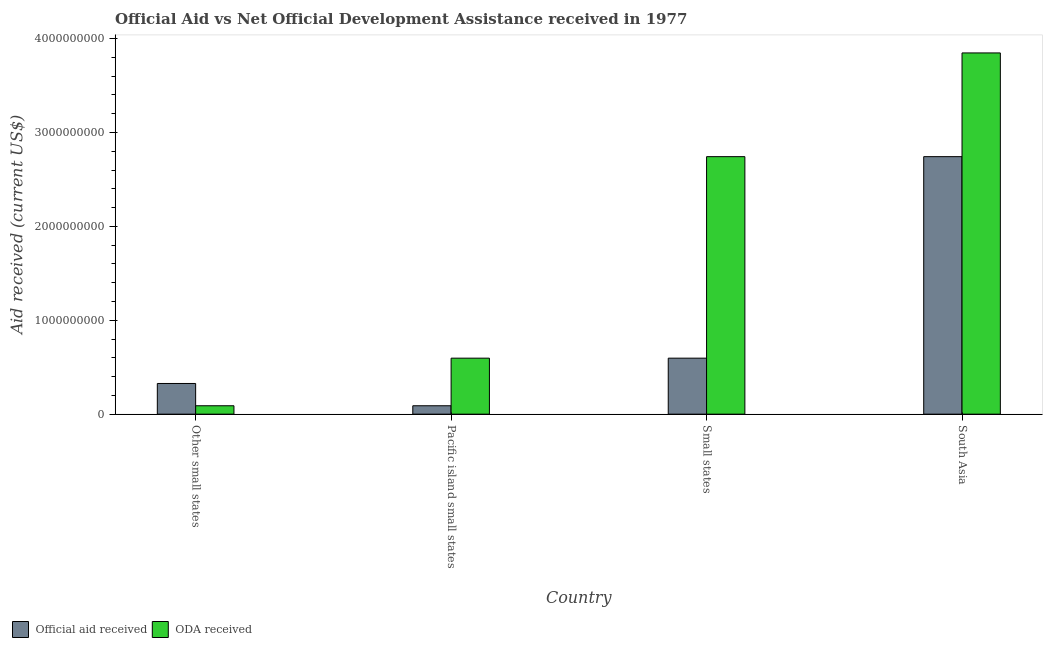Are the number of bars per tick equal to the number of legend labels?
Provide a succinct answer. Yes. Are the number of bars on each tick of the X-axis equal?
Your answer should be very brief. Yes. How many bars are there on the 4th tick from the left?
Your answer should be compact. 2. What is the label of the 3rd group of bars from the left?
Offer a very short reply. Small states. What is the official aid received in South Asia?
Offer a terse response. 2.74e+09. Across all countries, what is the maximum oda received?
Your answer should be very brief. 3.85e+09. Across all countries, what is the minimum official aid received?
Provide a short and direct response. 8.96e+07. In which country was the oda received minimum?
Provide a succinct answer. Other small states. What is the total official aid received in the graph?
Offer a very short reply. 3.76e+09. What is the difference between the oda received in Pacific island small states and that in Small states?
Keep it short and to the point. -2.15e+09. What is the difference between the official aid received in Small states and the oda received in South Asia?
Offer a terse response. -3.25e+09. What is the average official aid received per country?
Offer a terse response. 9.39e+08. What is the difference between the official aid received and oda received in Small states?
Ensure brevity in your answer.  -2.15e+09. In how many countries, is the oda received greater than 3800000000 US$?
Your answer should be compact. 1. What is the ratio of the oda received in Other small states to that in Small states?
Give a very brief answer. 0.03. Is the difference between the oda received in Other small states and South Asia greater than the difference between the official aid received in Other small states and South Asia?
Your response must be concise. No. What is the difference between the highest and the second highest oda received?
Provide a succinct answer. 1.10e+09. What is the difference between the highest and the lowest official aid received?
Your response must be concise. 2.65e+09. What does the 1st bar from the left in Other small states represents?
Your answer should be compact. Official aid received. What does the 1st bar from the right in Small states represents?
Your answer should be compact. ODA received. How many bars are there?
Offer a terse response. 8. What is the difference between two consecutive major ticks on the Y-axis?
Provide a succinct answer. 1.00e+09. Does the graph contain any zero values?
Ensure brevity in your answer.  No. Does the graph contain grids?
Offer a very short reply. No. How are the legend labels stacked?
Make the answer very short. Horizontal. What is the title of the graph?
Make the answer very short. Official Aid vs Net Official Development Assistance received in 1977 . Does "Chemicals" appear as one of the legend labels in the graph?
Your answer should be very brief. No. What is the label or title of the Y-axis?
Your answer should be compact. Aid received (current US$). What is the Aid received (current US$) in Official aid received in Other small states?
Provide a succinct answer. 3.27e+08. What is the Aid received (current US$) in ODA received in Other small states?
Offer a very short reply. 8.96e+07. What is the Aid received (current US$) of Official aid received in Pacific island small states?
Keep it short and to the point. 8.96e+07. What is the Aid received (current US$) of ODA received in Pacific island small states?
Provide a succinct answer. 5.96e+08. What is the Aid received (current US$) in Official aid received in Small states?
Your response must be concise. 5.96e+08. What is the Aid received (current US$) of ODA received in Small states?
Offer a very short reply. 2.74e+09. What is the Aid received (current US$) of Official aid received in South Asia?
Your answer should be compact. 2.74e+09. What is the Aid received (current US$) in ODA received in South Asia?
Your answer should be compact. 3.85e+09. Across all countries, what is the maximum Aid received (current US$) of Official aid received?
Offer a terse response. 2.74e+09. Across all countries, what is the maximum Aid received (current US$) in ODA received?
Keep it short and to the point. 3.85e+09. Across all countries, what is the minimum Aid received (current US$) of Official aid received?
Offer a terse response. 8.96e+07. Across all countries, what is the minimum Aid received (current US$) of ODA received?
Your answer should be compact. 8.96e+07. What is the total Aid received (current US$) of Official aid received in the graph?
Provide a succinct answer. 3.76e+09. What is the total Aid received (current US$) in ODA received in the graph?
Provide a succinct answer. 7.28e+09. What is the difference between the Aid received (current US$) in Official aid received in Other small states and that in Pacific island small states?
Your answer should be compact. 2.37e+08. What is the difference between the Aid received (current US$) of ODA received in Other small states and that in Pacific island small states?
Provide a succinct answer. -5.07e+08. What is the difference between the Aid received (current US$) in Official aid received in Other small states and that in Small states?
Your response must be concise. -2.70e+08. What is the difference between the Aid received (current US$) in ODA received in Other small states and that in Small states?
Provide a short and direct response. -2.65e+09. What is the difference between the Aid received (current US$) of Official aid received in Other small states and that in South Asia?
Give a very brief answer. -2.42e+09. What is the difference between the Aid received (current US$) in ODA received in Other small states and that in South Asia?
Provide a succinct answer. -3.76e+09. What is the difference between the Aid received (current US$) of Official aid received in Pacific island small states and that in Small states?
Your answer should be very brief. -5.07e+08. What is the difference between the Aid received (current US$) of ODA received in Pacific island small states and that in Small states?
Make the answer very short. -2.15e+09. What is the difference between the Aid received (current US$) in Official aid received in Pacific island small states and that in South Asia?
Give a very brief answer. -2.65e+09. What is the difference between the Aid received (current US$) in ODA received in Pacific island small states and that in South Asia?
Provide a succinct answer. -3.25e+09. What is the difference between the Aid received (current US$) in Official aid received in Small states and that in South Asia?
Your response must be concise. -2.15e+09. What is the difference between the Aid received (current US$) in ODA received in Small states and that in South Asia?
Provide a succinct answer. -1.10e+09. What is the difference between the Aid received (current US$) of Official aid received in Other small states and the Aid received (current US$) of ODA received in Pacific island small states?
Provide a short and direct response. -2.70e+08. What is the difference between the Aid received (current US$) in Official aid received in Other small states and the Aid received (current US$) in ODA received in Small states?
Make the answer very short. -2.42e+09. What is the difference between the Aid received (current US$) in Official aid received in Other small states and the Aid received (current US$) in ODA received in South Asia?
Offer a very short reply. -3.52e+09. What is the difference between the Aid received (current US$) of Official aid received in Pacific island small states and the Aid received (current US$) of ODA received in Small states?
Ensure brevity in your answer.  -2.65e+09. What is the difference between the Aid received (current US$) of Official aid received in Pacific island small states and the Aid received (current US$) of ODA received in South Asia?
Your answer should be compact. -3.76e+09. What is the difference between the Aid received (current US$) in Official aid received in Small states and the Aid received (current US$) in ODA received in South Asia?
Keep it short and to the point. -3.25e+09. What is the average Aid received (current US$) of Official aid received per country?
Offer a terse response. 9.39e+08. What is the average Aid received (current US$) in ODA received per country?
Offer a very short reply. 1.82e+09. What is the difference between the Aid received (current US$) in Official aid received and Aid received (current US$) in ODA received in Other small states?
Give a very brief answer. 2.37e+08. What is the difference between the Aid received (current US$) of Official aid received and Aid received (current US$) of ODA received in Pacific island small states?
Your answer should be compact. -5.07e+08. What is the difference between the Aid received (current US$) in Official aid received and Aid received (current US$) in ODA received in Small states?
Ensure brevity in your answer.  -2.15e+09. What is the difference between the Aid received (current US$) in Official aid received and Aid received (current US$) in ODA received in South Asia?
Ensure brevity in your answer.  -1.10e+09. What is the ratio of the Aid received (current US$) in Official aid received in Other small states to that in Pacific island small states?
Ensure brevity in your answer.  3.65. What is the ratio of the Aid received (current US$) of ODA received in Other small states to that in Pacific island small states?
Provide a short and direct response. 0.15. What is the ratio of the Aid received (current US$) of Official aid received in Other small states to that in Small states?
Give a very brief answer. 0.55. What is the ratio of the Aid received (current US$) of ODA received in Other small states to that in Small states?
Offer a terse response. 0.03. What is the ratio of the Aid received (current US$) of Official aid received in Other small states to that in South Asia?
Ensure brevity in your answer.  0.12. What is the ratio of the Aid received (current US$) in ODA received in Other small states to that in South Asia?
Your answer should be compact. 0.02. What is the ratio of the Aid received (current US$) of Official aid received in Pacific island small states to that in Small states?
Provide a short and direct response. 0.15. What is the ratio of the Aid received (current US$) of ODA received in Pacific island small states to that in Small states?
Offer a terse response. 0.22. What is the ratio of the Aid received (current US$) in Official aid received in Pacific island small states to that in South Asia?
Offer a very short reply. 0.03. What is the ratio of the Aid received (current US$) of ODA received in Pacific island small states to that in South Asia?
Your answer should be very brief. 0.15. What is the ratio of the Aid received (current US$) in Official aid received in Small states to that in South Asia?
Your response must be concise. 0.22. What is the ratio of the Aid received (current US$) in ODA received in Small states to that in South Asia?
Offer a terse response. 0.71. What is the difference between the highest and the second highest Aid received (current US$) in Official aid received?
Make the answer very short. 2.15e+09. What is the difference between the highest and the second highest Aid received (current US$) of ODA received?
Your answer should be compact. 1.10e+09. What is the difference between the highest and the lowest Aid received (current US$) of Official aid received?
Offer a terse response. 2.65e+09. What is the difference between the highest and the lowest Aid received (current US$) in ODA received?
Keep it short and to the point. 3.76e+09. 